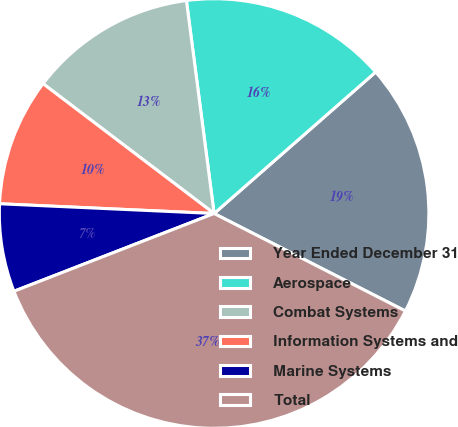Convert chart to OTSL. <chart><loc_0><loc_0><loc_500><loc_500><pie_chart><fcel>Year Ended December 31<fcel>Aerospace<fcel>Combat Systems<fcel>Information Systems and<fcel>Marine Systems<fcel>Total<nl><fcel>18.95%<fcel>15.61%<fcel>12.61%<fcel>9.61%<fcel>6.62%<fcel>36.6%<nl></chart> 